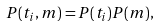Convert formula to latex. <formula><loc_0><loc_0><loc_500><loc_500>P ( t _ { i } , m ) = P ( t _ { i } ) P ( m ) ,</formula> 